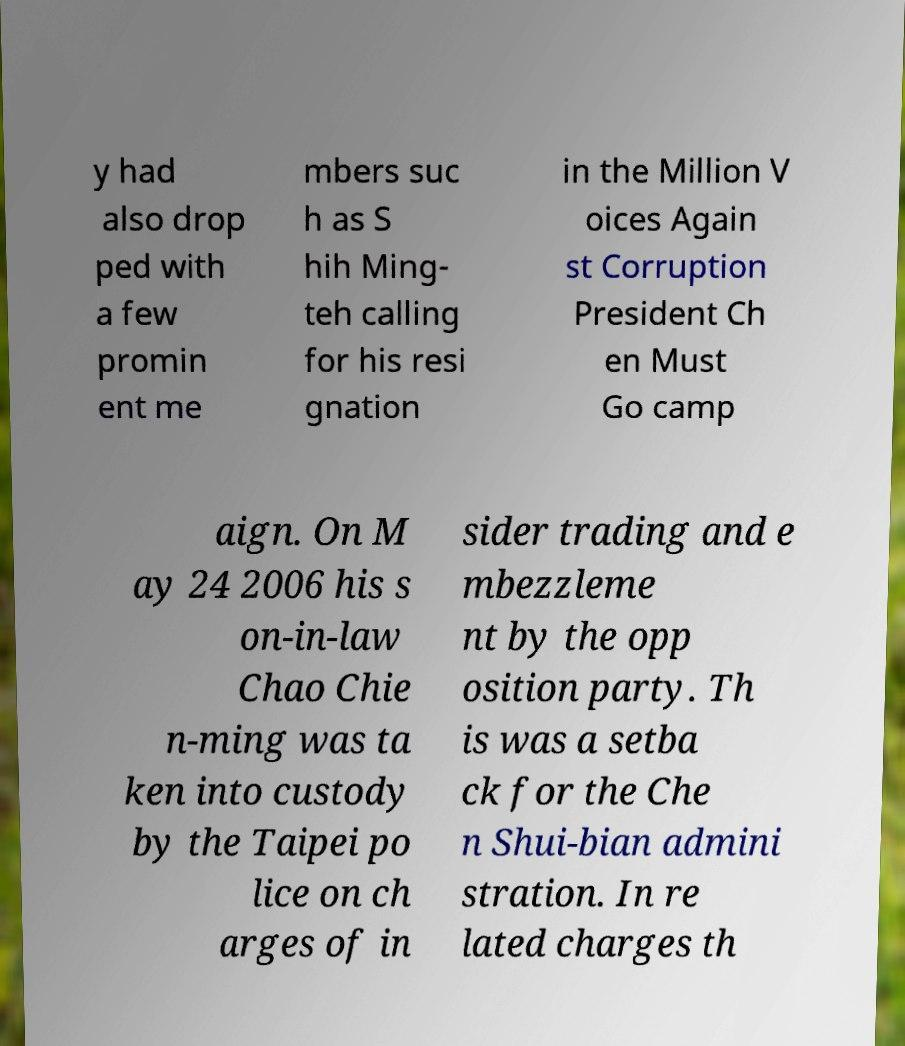I need the written content from this picture converted into text. Can you do that? y had also drop ped with a few promin ent me mbers suc h as S hih Ming- teh calling for his resi gnation in the Million V oices Again st Corruption President Ch en Must Go camp aign. On M ay 24 2006 his s on-in-law Chao Chie n-ming was ta ken into custody by the Taipei po lice on ch arges of in sider trading and e mbezzleme nt by the opp osition party. Th is was a setba ck for the Che n Shui-bian admini stration. In re lated charges th 